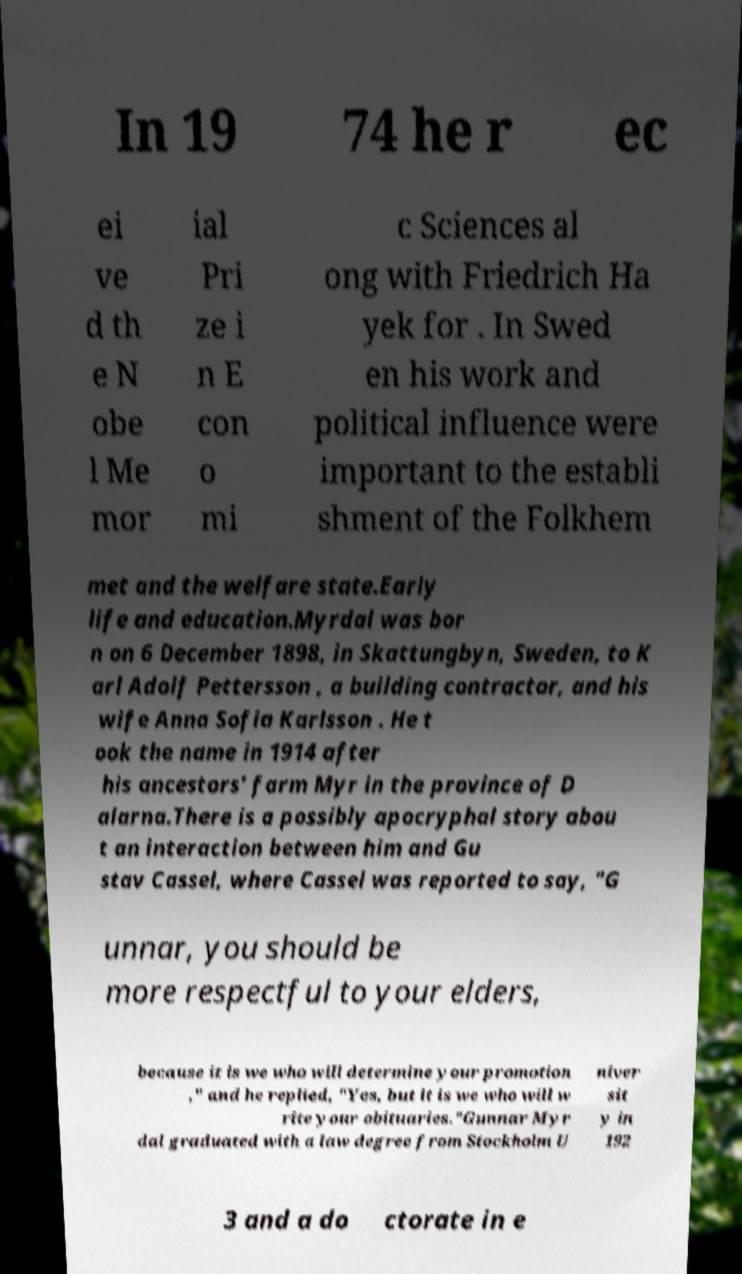Can you read and provide the text displayed in the image?This photo seems to have some interesting text. Can you extract and type it out for me? In 19 74 he r ec ei ve d th e N obe l Me mor ial Pri ze i n E con o mi c Sciences al ong with Friedrich Ha yek for . In Swed en his work and political influence were important to the establi shment of the Folkhem met and the welfare state.Early life and education.Myrdal was bor n on 6 December 1898, in Skattungbyn, Sweden, to K arl Adolf Pettersson , a building contractor, and his wife Anna Sofia Karlsson . He t ook the name in 1914 after his ancestors' farm Myr in the province of D alarna.There is a possibly apocryphal story abou t an interaction between him and Gu stav Cassel, where Cassel was reported to say, "G unnar, you should be more respectful to your elders, because it is we who will determine your promotion ," and he replied, "Yes, but it is we who will w rite your obituaries."Gunnar Myr dal graduated with a law degree from Stockholm U niver sit y in 192 3 and a do ctorate in e 